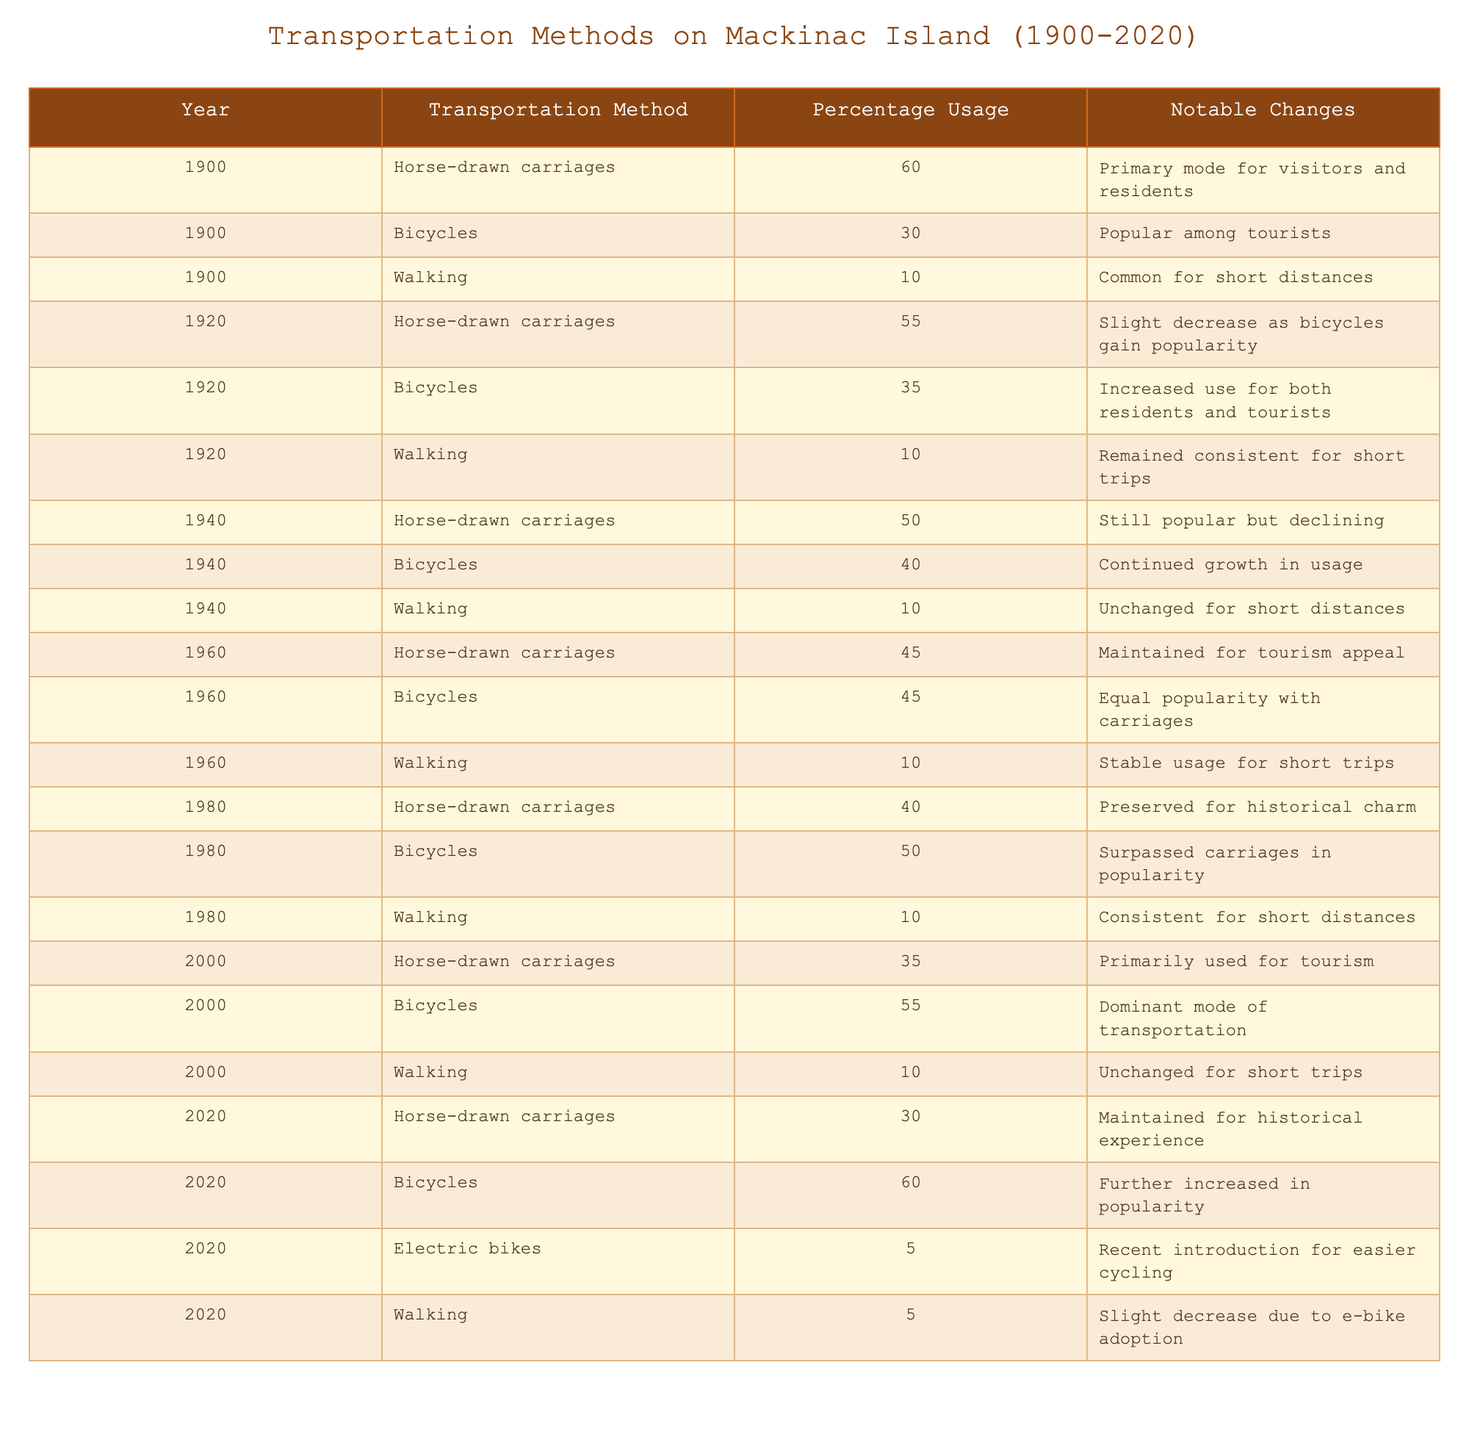What was the percentage usage of horse-drawn carriages in 1900? Referring to the table, in the year 1900, the percentage usage of horse-drawn carriages is explicitly stated as 60%.
Answer: 60% In which year did bicycles surpass horse-drawn carriages in popularity? By examining the table, bicycles surpassed horse-drawn carriages in popularity in the year 1980, where bicycles had 50% while horse-drawn carriages had 40%.
Answer: 1980 What was the percentage of walking as a transportation method in 1960? Looking at the table, in the year 1960, walking had a percentage usage of 10%.
Answer: 10% Which transportation method had the lowest usage in 2020? In 2020, electric bikes had a percentage usage of 5%, which is lower than walking (5%) and horse-drawn carriages (30%). However, in terms of specific numbers, electric bikes had the lowest usage.
Answer: Electric bikes What was the overall trend of horse-drawn carriages from 1900 to 2020? Observing the table, the usage of horse-drawn carriages decreased from 60% in 1900 to 30% in 2020, indicating a declining trend over the years.
Answer: Declining trend Calculate the average percentage usage of bicycles from 1900 to 2020. The bicycle percentages over the years are 30, 35, 40, 45, 50, 55, and 60. Summing these: (30 + 35 + 40 + 45 + 50 + 55 + 60) = 315. There are 7 data points, so the average is 315/7 = 45.
Answer: 45 True or False: Walking saw an increase in its usage percentage from 1900 to 2020. By examining the table, walking's percentage remained at 10% for many years (1900, 1920, 1940, 1960, 1980, and 2000), and then decreased to 5% in 2020, indicating a decrease, not an increase.
Answer: False What notable changes occurred for bicycles from 1920 to 1960? The table shows that from 1920 to 1960, the percentage usage of bicycles increased from 35% to 45%, highlighting a notable growth in popularity during that period.
Answer: Increased popularity How did the percentage of walking change between 2000 and 2020? In 2000, walking was at 10%, and by 2020 it was reduced to 5%, indicating a decrease of 5 percentage points over this period.
Answer: Decreased by 5% What was the percentage usage of bicycles in 1940 compared to 1980? In 1940, the usage of bicycles was 40%, while in 1980 it increased to 50%, showing a growth of 10 percentage points over that period.
Answer: Increased by 10% 